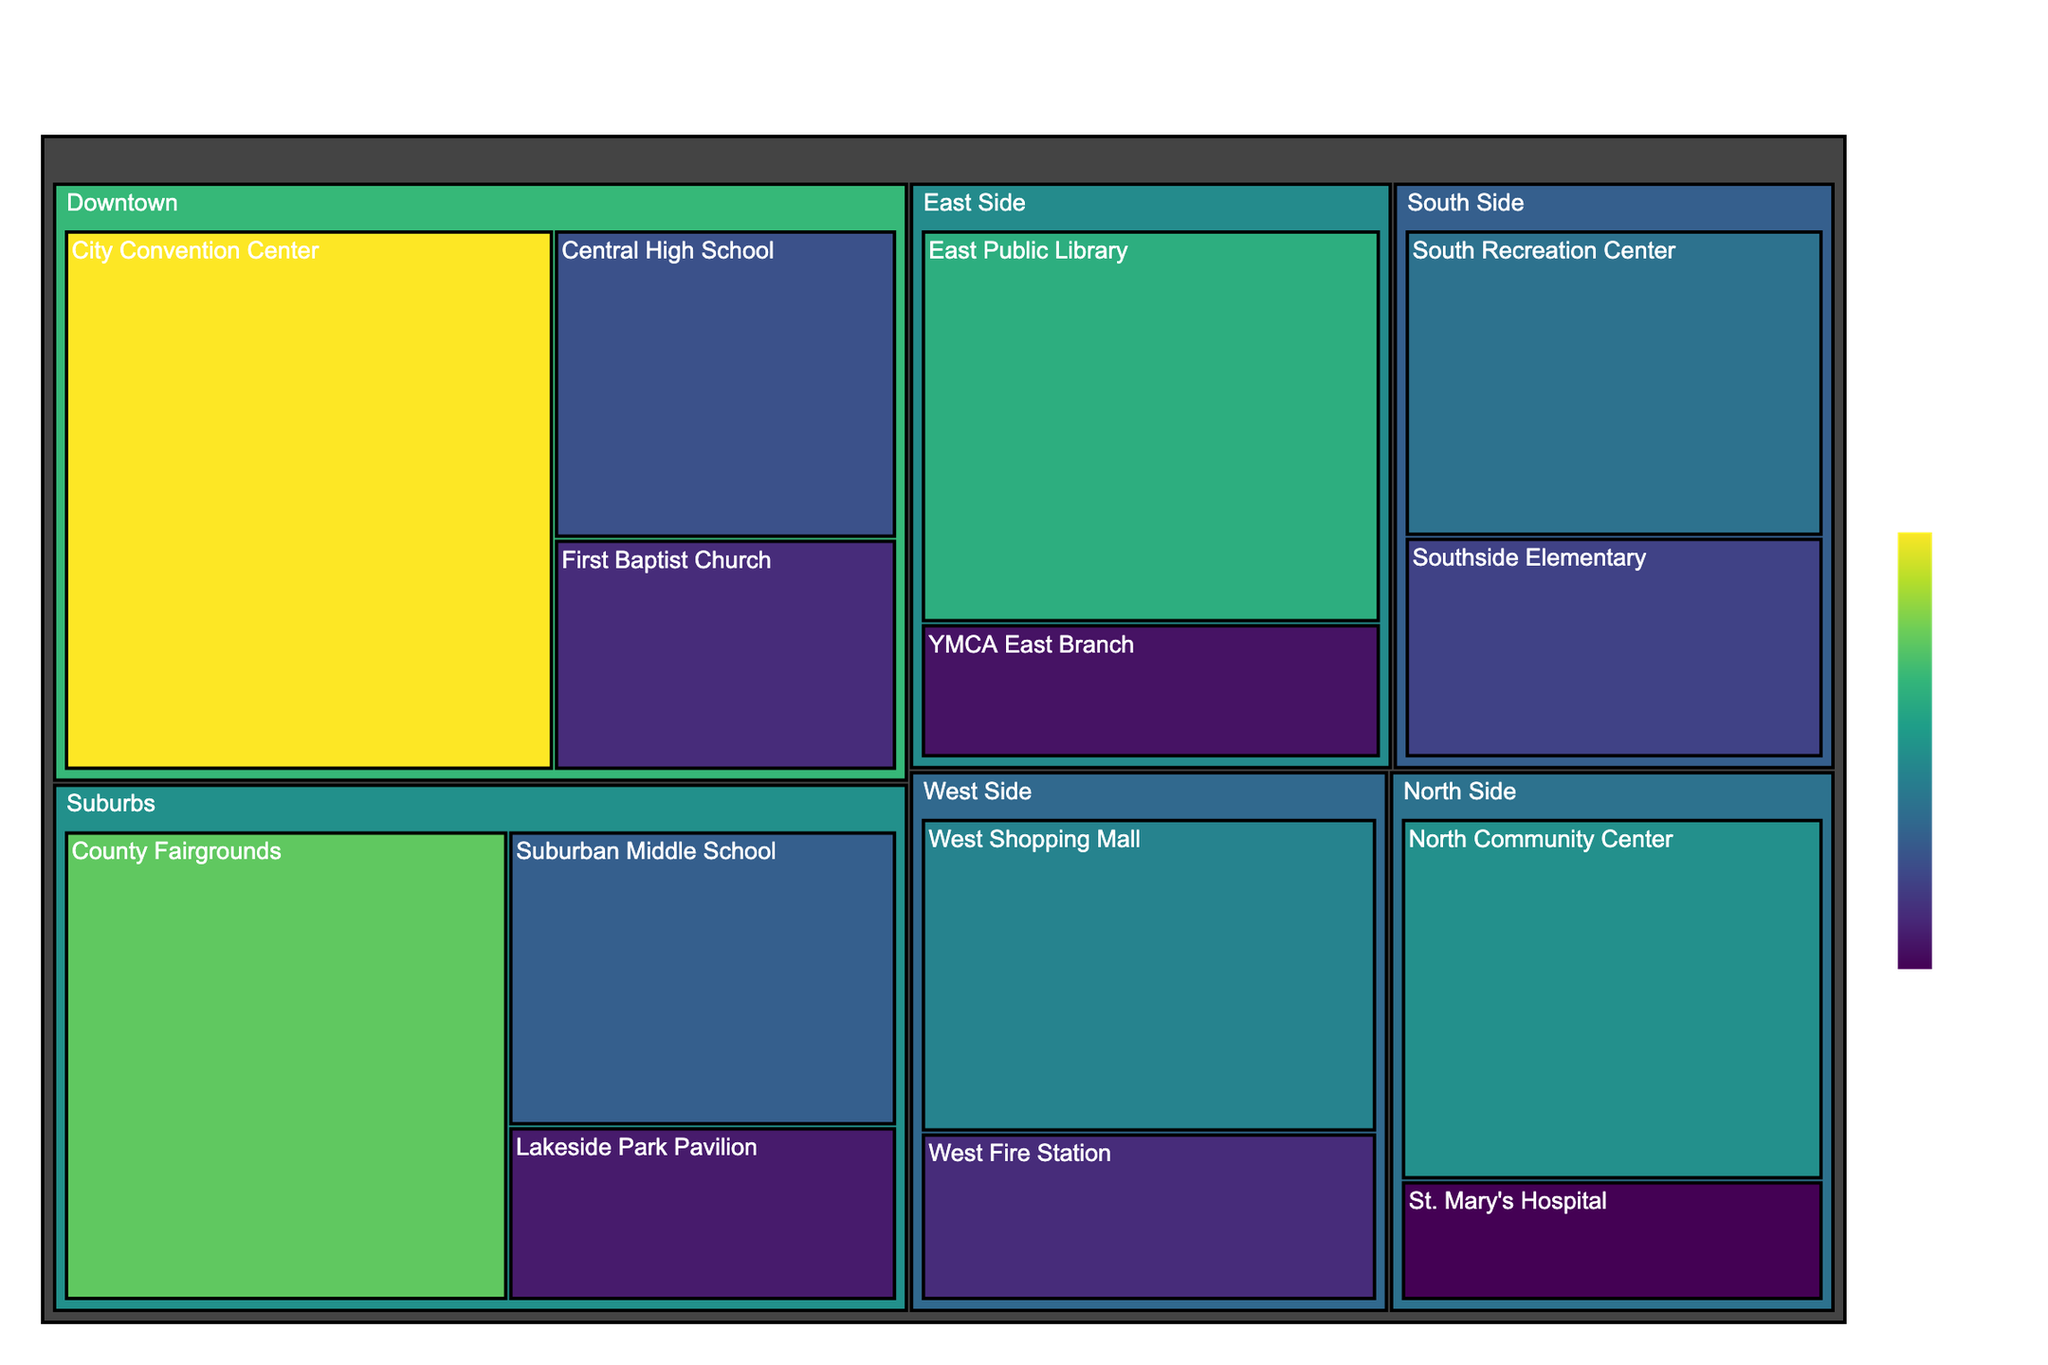what is the title of the figure? The title is found at the top of the figure and usually provides a brief overview of the main content. In this case, the title is "Emergency Shelter Distribution by Location and Capacity".
Answer: Emergency Shelter Distribution by Location and Capacity How many shelters are located in the Downtown area? Look for the "Downtown" section within the figure and count the number of individual boxes representing shelters.
Answer: 3 Which location has the shelter with the highest capacity? Identify the box with the largest area and highest value in the color scale. It belongs to a specific location as indicated by the hierarchy in the figure.
Answer: Downtown What is the total capacity of shelters located in the North Side? Add the capacities of all shelters located in the North Side: North Community Center (300) and St. Mary's Hospital (100).
Answer: 400 How does the capacity of the West Shopping Mall compare to the East Public Library? Look for both shelters within the figure and compare their capacities by examining their sizes and values.
Answer: West Shopping Mall has a smaller capacity (280) than the East Public Library (350) Which location has the most shelters? Count the number of individual shelter boxes within each location section.
Answer: Suburbs How many shelters have a capacity of 150? Identify and count all shelters with a capacity value of 150 within the figure.
Answer: 3 What is the average capacity of shelters in the Suburbs? Sum the capacities of all shelters in the Suburbs (400 + 220 + 130) and divide by the total number of Suburban shelters (3).
Answer: 250 What location has the smallest total shelter capacity? Sum the capacities of shelters for each location and compare the totals to identify the smallest one.
Answer: South Side Which location has shelters with the most uniform capacity distribution? Evaluate and compare the variation in shelter capacities within each location by looking at the consistency of the sizes and colors of the boxes.
Answer: North Side 